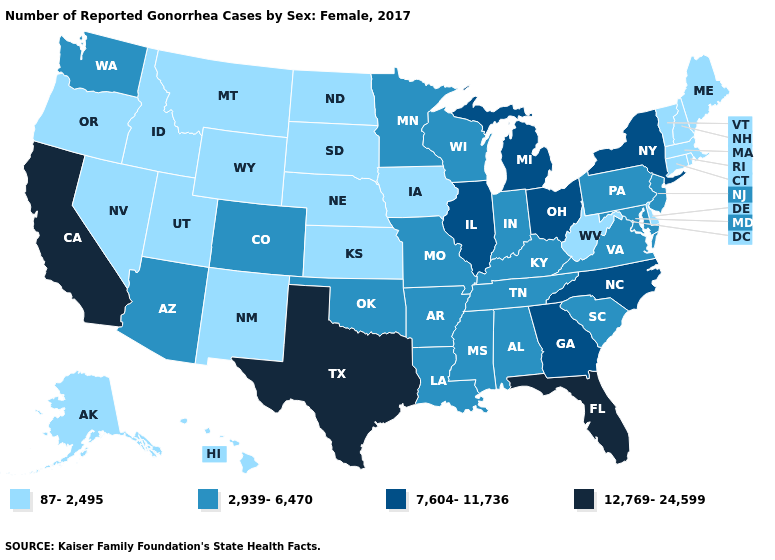Which states have the lowest value in the USA?
Short answer required. Alaska, Connecticut, Delaware, Hawaii, Idaho, Iowa, Kansas, Maine, Massachusetts, Montana, Nebraska, Nevada, New Hampshire, New Mexico, North Dakota, Oregon, Rhode Island, South Dakota, Utah, Vermont, West Virginia, Wyoming. What is the value of New Jersey?
Concise answer only. 2,939-6,470. What is the lowest value in the Northeast?
Give a very brief answer. 87-2,495. How many symbols are there in the legend?
Be succinct. 4. Among the states that border West Virginia , which have the highest value?
Short answer required. Ohio. What is the value of Louisiana?
Be succinct. 2,939-6,470. Among the states that border Nevada , which have the highest value?
Concise answer only. California. Which states have the highest value in the USA?
Quick response, please. California, Florida, Texas. Does Virginia have the same value as Nebraska?
Keep it brief. No. Does Nevada have the lowest value in the USA?
Be succinct. Yes. Which states hav the highest value in the South?
Short answer required. Florida, Texas. Does the first symbol in the legend represent the smallest category?
Be succinct. Yes. What is the lowest value in the West?
Be succinct. 87-2,495. Among the states that border Mississippi , which have the highest value?
Quick response, please. Alabama, Arkansas, Louisiana, Tennessee. What is the value of Wyoming?
Quick response, please. 87-2,495. 